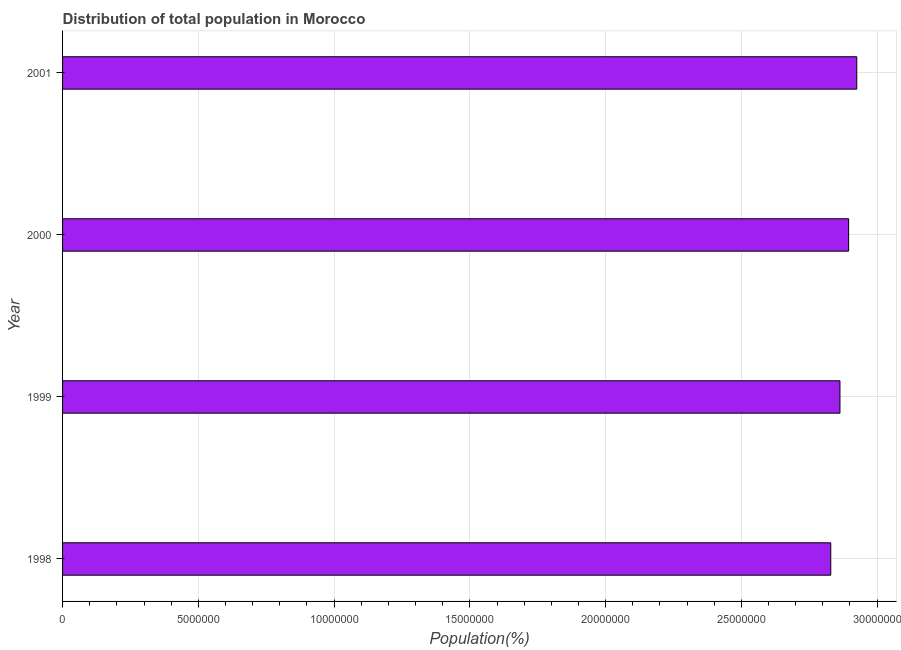What is the title of the graph?
Provide a short and direct response. Distribution of total population in Morocco . What is the label or title of the X-axis?
Offer a terse response. Population(%). What is the label or title of the Y-axis?
Ensure brevity in your answer.  Year. What is the population in 2000?
Offer a terse response. 2.90e+07. Across all years, what is the maximum population?
Provide a short and direct response. 2.93e+07. Across all years, what is the minimum population?
Make the answer very short. 2.83e+07. In which year was the population minimum?
Your response must be concise. 1998. What is the sum of the population?
Ensure brevity in your answer.  1.15e+08. What is the difference between the population in 1998 and 2000?
Keep it short and to the point. -6.58e+05. What is the average population per year?
Provide a short and direct response. 2.88e+07. What is the median population?
Offer a terse response. 2.88e+07. In how many years, is the population greater than 20000000 %?
Your answer should be very brief. 4. Do a majority of the years between 1998 and 2001 (inclusive) have population greater than 26000000 %?
Provide a short and direct response. Yes. Is the difference between the population in 1998 and 1999 greater than the difference between any two years?
Your answer should be compact. No. What is the difference between the highest and the second highest population?
Provide a short and direct response. 3.00e+05. What is the difference between the highest and the lowest population?
Keep it short and to the point. 9.59e+05. In how many years, is the population greater than the average population taken over all years?
Provide a succinct answer. 2. Are all the bars in the graph horizontal?
Keep it short and to the point. Yes. How many years are there in the graph?
Your response must be concise. 4. Are the values on the major ticks of X-axis written in scientific E-notation?
Make the answer very short. No. What is the Population(%) of 1998?
Your answer should be compact. 2.83e+07. What is the Population(%) in 1999?
Provide a short and direct response. 2.86e+07. What is the Population(%) in 2000?
Ensure brevity in your answer.  2.90e+07. What is the Population(%) of 2001?
Offer a terse response. 2.93e+07. What is the difference between the Population(%) in 1998 and 1999?
Offer a very short reply. -3.39e+05. What is the difference between the Population(%) in 1998 and 2000?
Provide a short and direct response. -6.58e+05. What is the difference between the Population(%) in 1998 and 2001?
Make the answer very short. -9.59e+05. What is the difference between the Population(%) in 1999 and 2000?
Make the answer very short. -3.20e+05. What is the difference between the Population(%) in 1999 and 2001?
Your answer should be compact. -6.20e+05. What is the difference between the Population(%) in 2000 and 2001?
Provide a succinct answer. -3.00e+05. What is the ratio of the Population(%) in 1999 to that in 2000?
Keep it short and to the point. 0.99. 